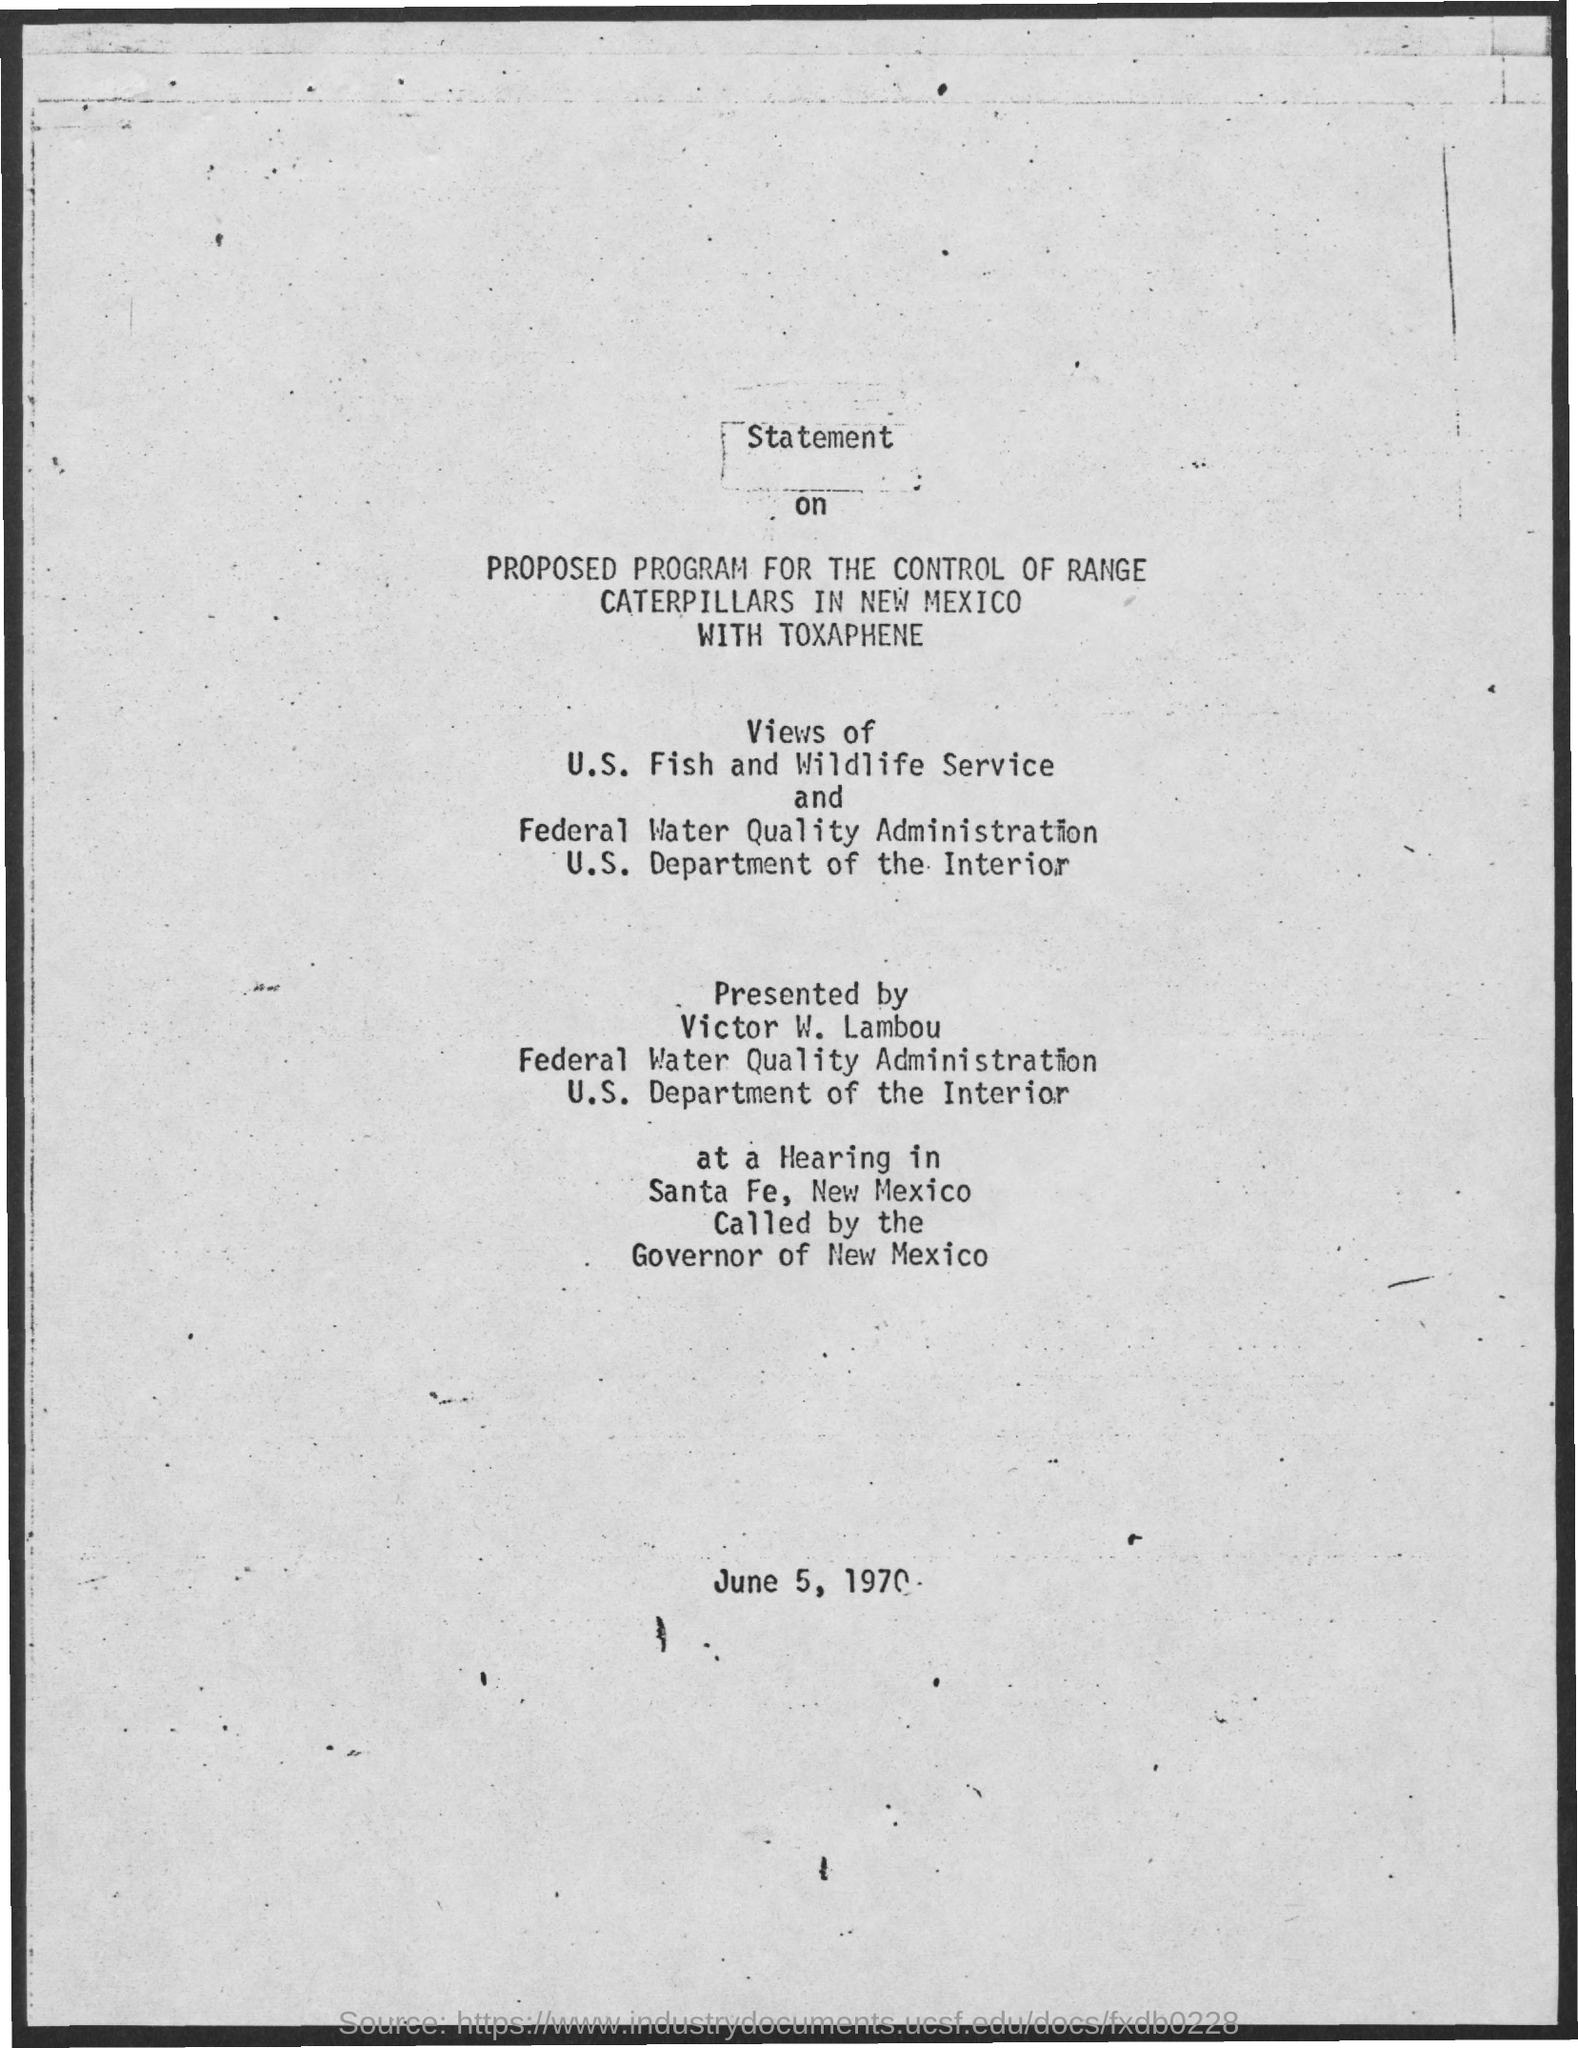What is the date mentioned ?
Provide a succinct answer. June 5 , 1970. 